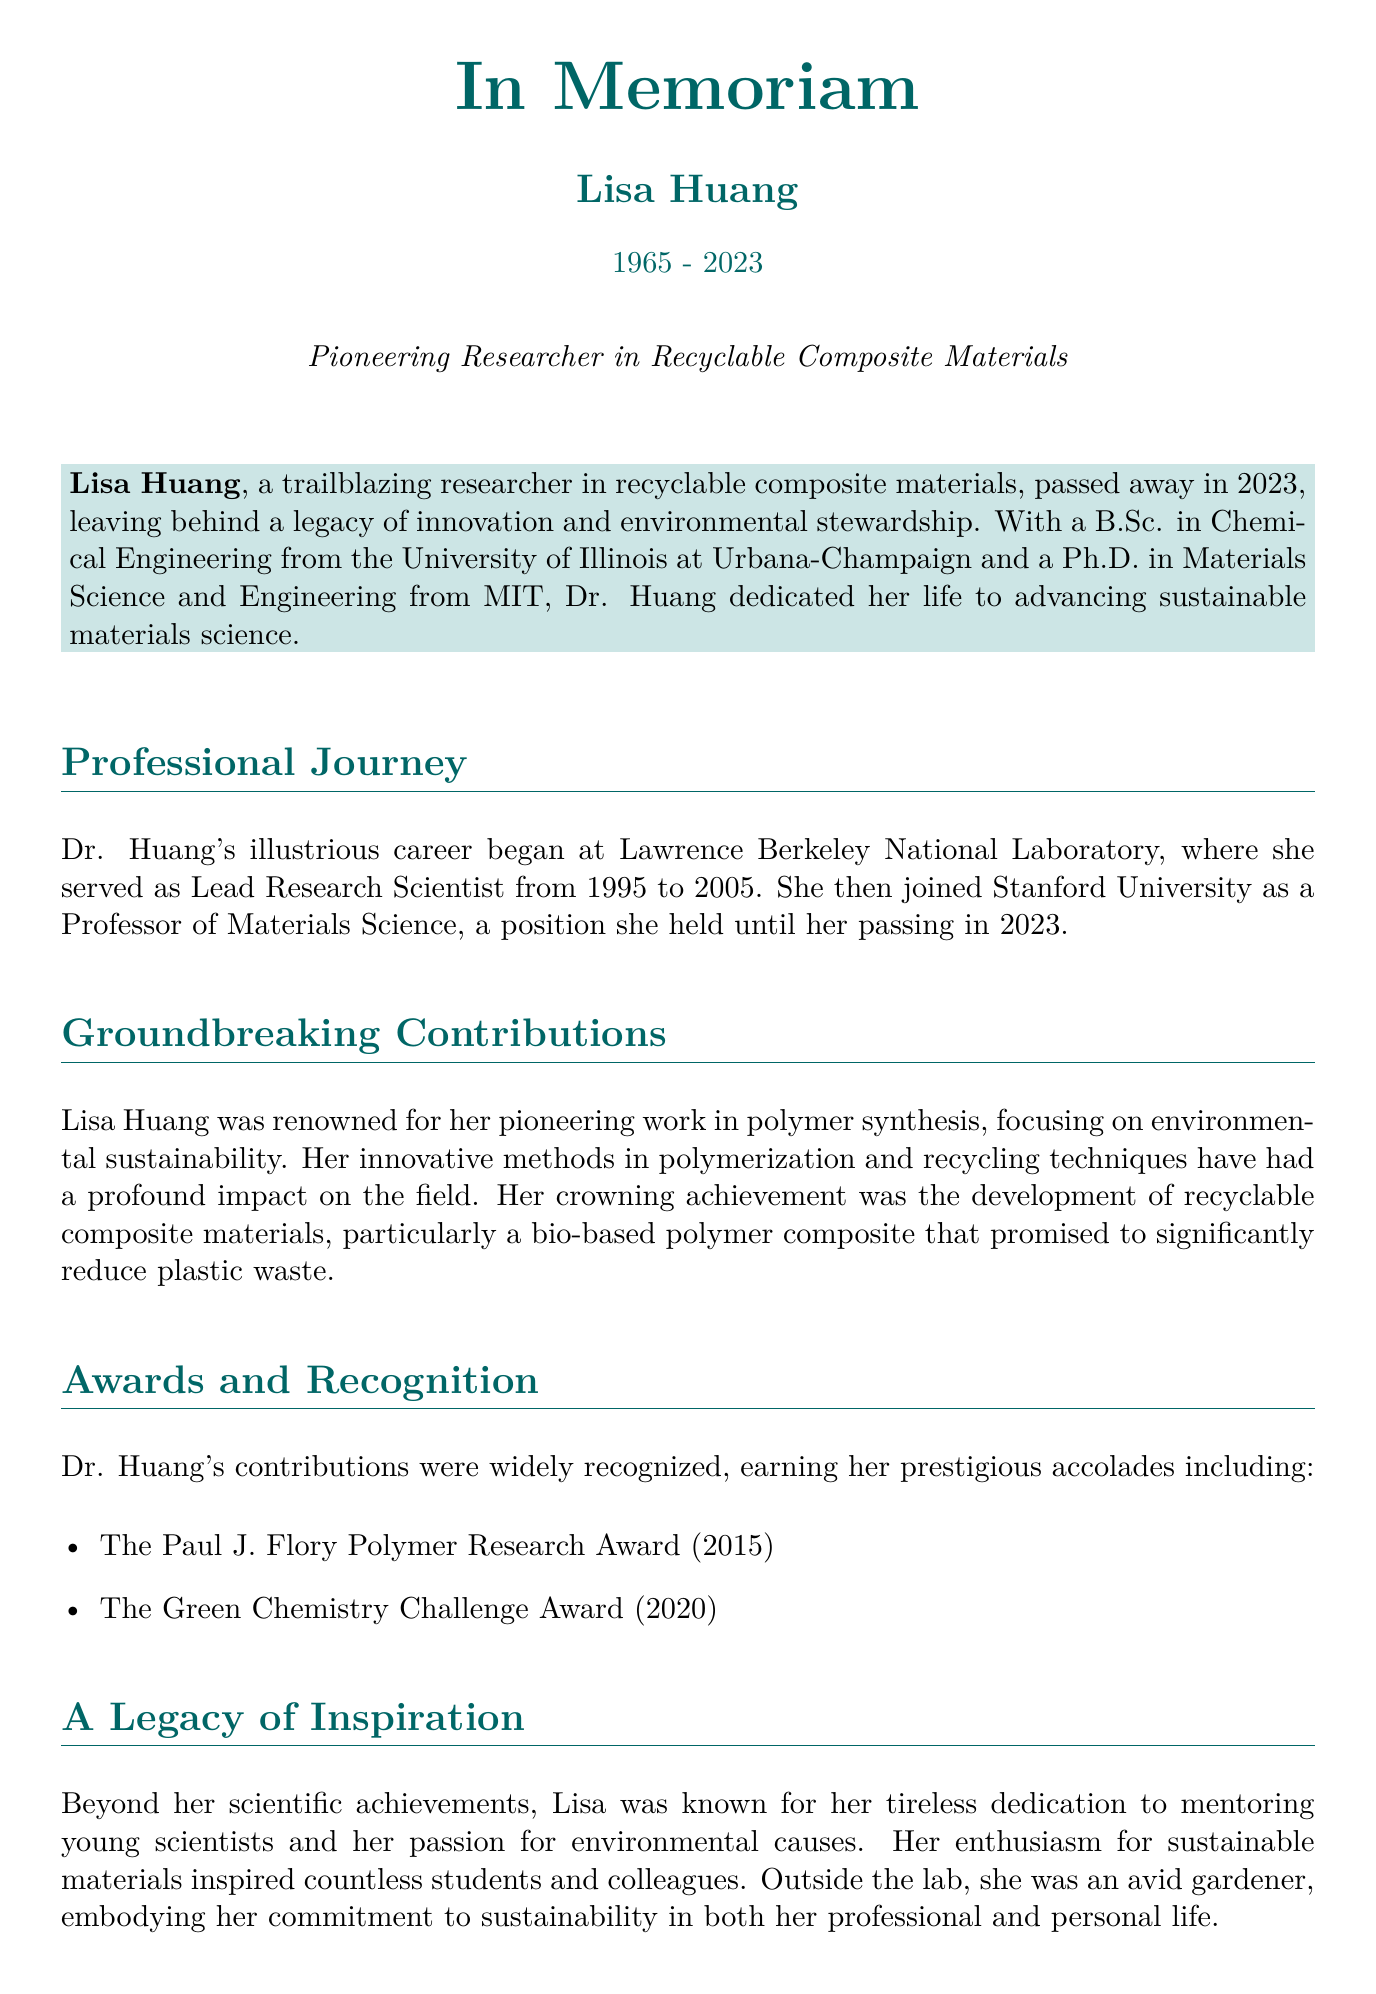What is the full name of the researcher? The document states her full name in the title section, which is "Lisa Huang."
Answer: Lisa Huang What year did Lisa Huang pass away? The document clearly states the year of her passing as 2023.
Answer: 2023 What degree did Lisa Huang earn from the University of Illinois? The document mentions she obtained a B.Sc. in Chemical Engineering.
Answer: B.Sc. in Chemical Engineering Which prestigious award did she receive in 2020? The document lists her awards, including the Green Chemistry Challenge Award for the year 2020.
Answer: Green Chemistry Challenge Award What was Lisa Huang's notable achievement in polymer synthesis? The document highlights her development of recyclable composite materials, specifically a bio-based polymer composite.
Answer: Recyclable composite materials In which university did Lisa Huang serve as a professor? The document specifies that she was a professor at Stanford University.
Answer: Stanford University How many children did Lisa Huang have? The document mentions she is survived by two children, Emily and Michael.
Answer: Two What type of donations are suggested in lieu of flowers? The document suggests donations to the 'Lisa Huang Fellowship for Sustainable Materials' at Stanford University.
Answer: 'Lisa Huang Fellowship for Sustainable Materials' What personal hobby did Lisa Huang enjoy? The document states that she was an avid gardener, indicating her personal interest outside of her research.
Answer: Gardening 